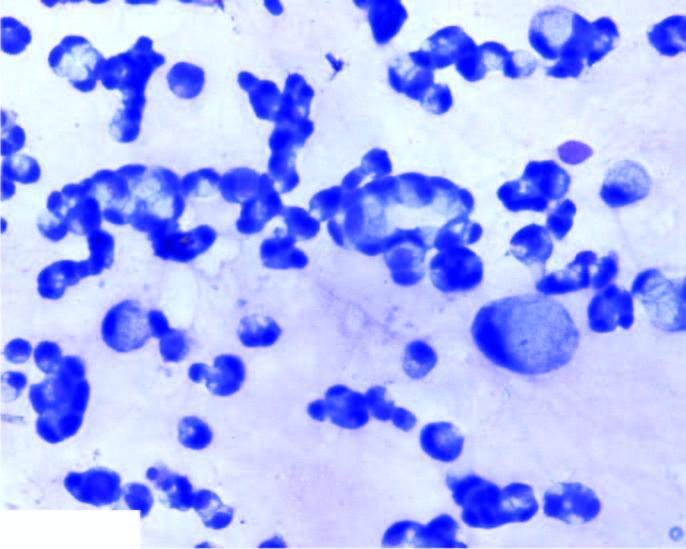re the periphery large number of malignant cells scattered singly or in small clusters having characteristic cytoplasmic vacuoles, nuclear hyperchromasia and prominent nucleoli?
Answer the question using a single word or phrase. No 